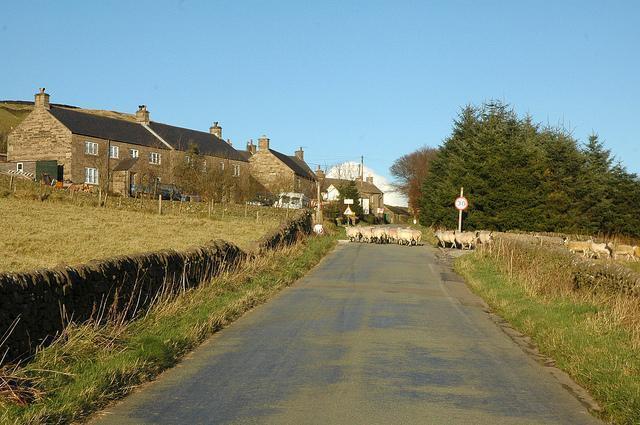When travelling this road for safety what should you allow to cross first?
Indicate the correct response and explain using: 'Answer: answer
Rationale: rationale.'
Options: Crickets, cars, sheep, flies. Answer: sheep.
Rationale: The sheep have to cross before anyone else can. 